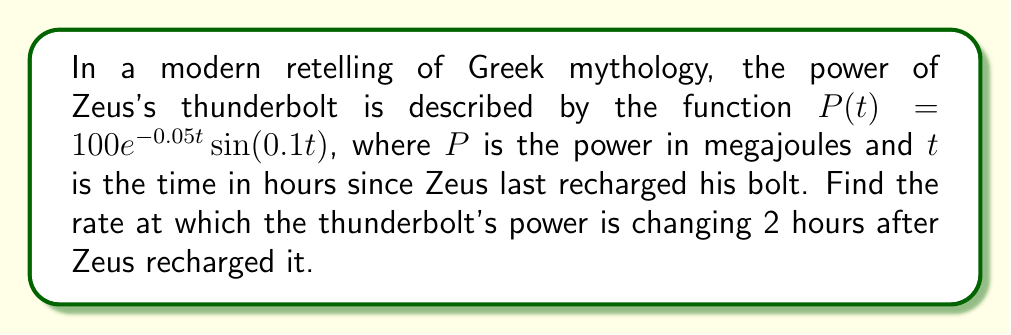Could you help me with this problem? To find the rate of change of the thunderbolt's power, we need to find the derivative of $P(t)$ and then evaluate it at $t=2$.

1. Let's start by applying the product rule to differentiate $P(t)$:
   $$\frac{d}{dt}[P(t)] = \frac{d}{dt}[100e^{-0.05t}] \cdot \sin(0.1t) + 100e^{-0.05t} \cdot \frac{d}{dt}[\sin(0.1t)]$$

2. Differentiate $100e^{-0.05t}$:
   $$\frac{d}{dt}[100e^{-0.05t}] = 100 \cdot (-0.05) \cdot e^{-0.05t} = -5e^{-0.05t}$$

3. Differentiate $\sin(0.1t)$:
   $$\frac{d}{dt}[\sin(0.1t)] = 0.1 \cdot \cos(0.1t)$$

4. Substitute these back into the product rule equation:
   $$\frac{d}{dt}[P(t)] = -5e^{-0.05t} \cdot \sin(0.1t) + 100e^{-0.05t} \cdot 0.1 \cos(0.1t)$$

5. Simplify:
   $$\frac{d}{dt}[P(t)] = e^{-0.05t}[-5\sin(0.1t) + 10\cos(0.1t)]$$

6. Now, evaluate this at $t=2$:
   $$\frac{d}{dt}[P(2)] = e^{-0.05(2)}[-5\sin(0.1(2)) + 10\cos(0.1(2))]$$
   $$= e^{-0.1}[-5\sin(0.2) + 10\cos(0.2)]$$

7. Calculate the numerical value:
   $$\approx 0.9048 \cdot [-5 \cdot 0.1987 + 10 \cdot 0.9801]$$
   $$\approx 0.9048 \cdot [-0.9935 + 9.801]$$
   $$\approx 0.9048 \cdot 8.8075$$
   $$\approx 7.97$$ megajoules per hour
Answer: $7.97$ MJ/h 